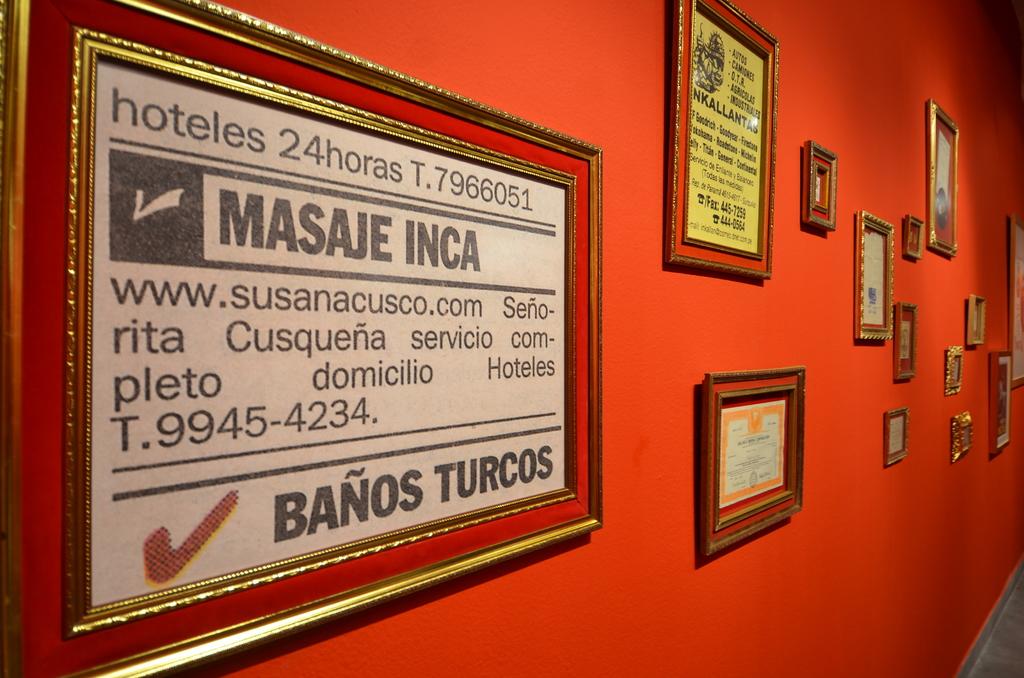What does it say next to the check mark?
Offer a very short reply. Banos turcos. What is their telephone number?
Give a very brief answer. 9945-4234. 